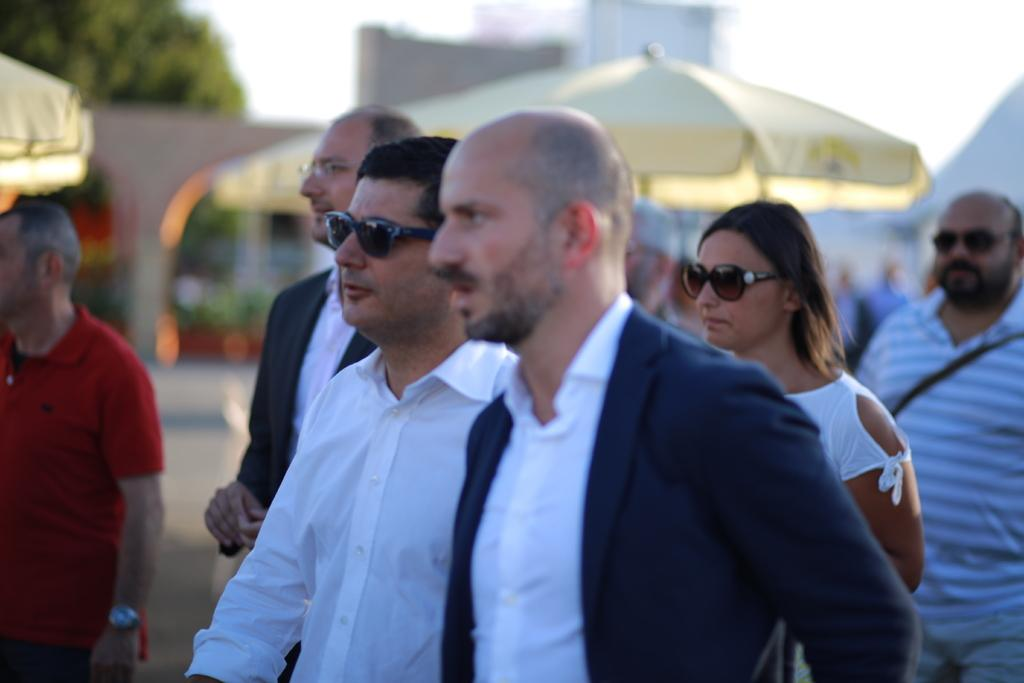What is the arrangement of the people in the image? The people are standing one beside the other in the image. What objects are present behind the people? There are umbrellas behind the people in the image. Can you describe the background of the image? There is a tree visible in the background on the left side top. What type of stitch is being used to sew the bell onto the man's shirt in the image? There is no man, bell, or stitching present in the image. 